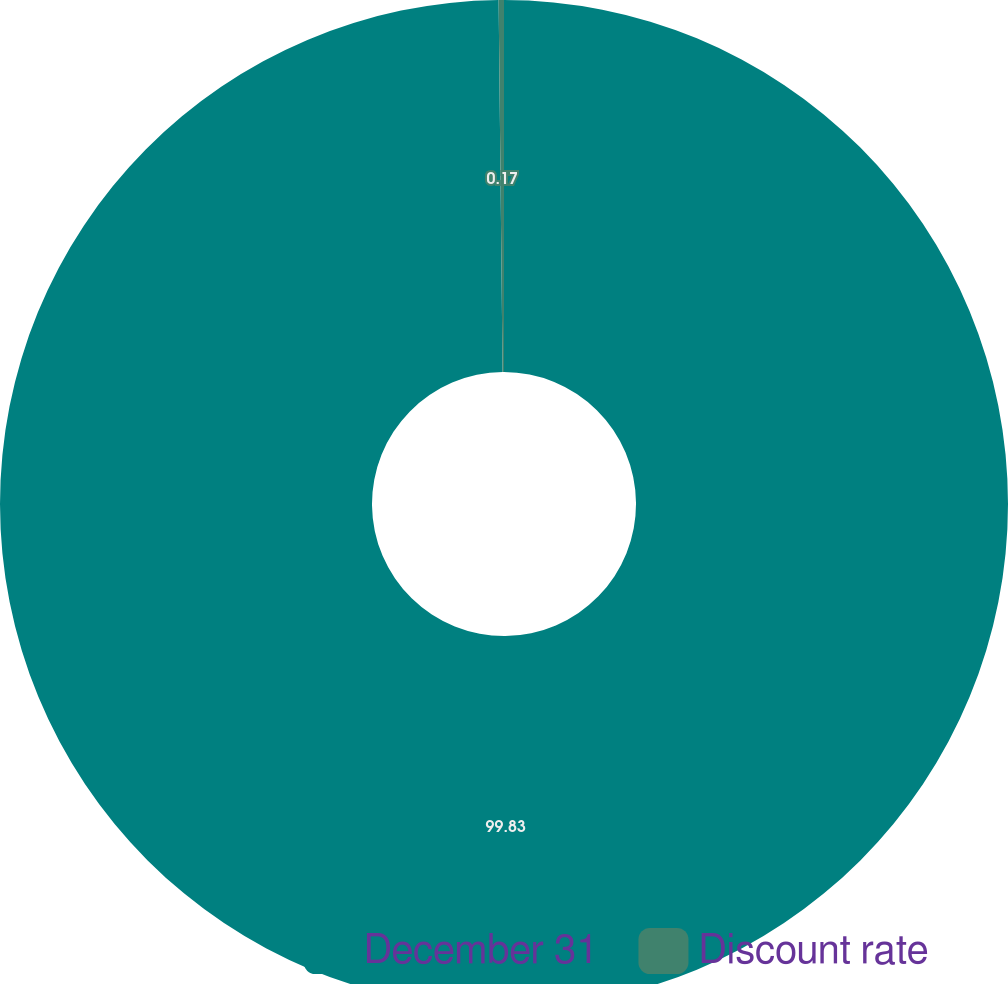<chart> <loc_0><loc_0><loc_500><loc_500><pie_chart><fcel>December 31<fcel>Discount rate<nl><fcel>99.83%<fcel>0.17%<nl></chart> 